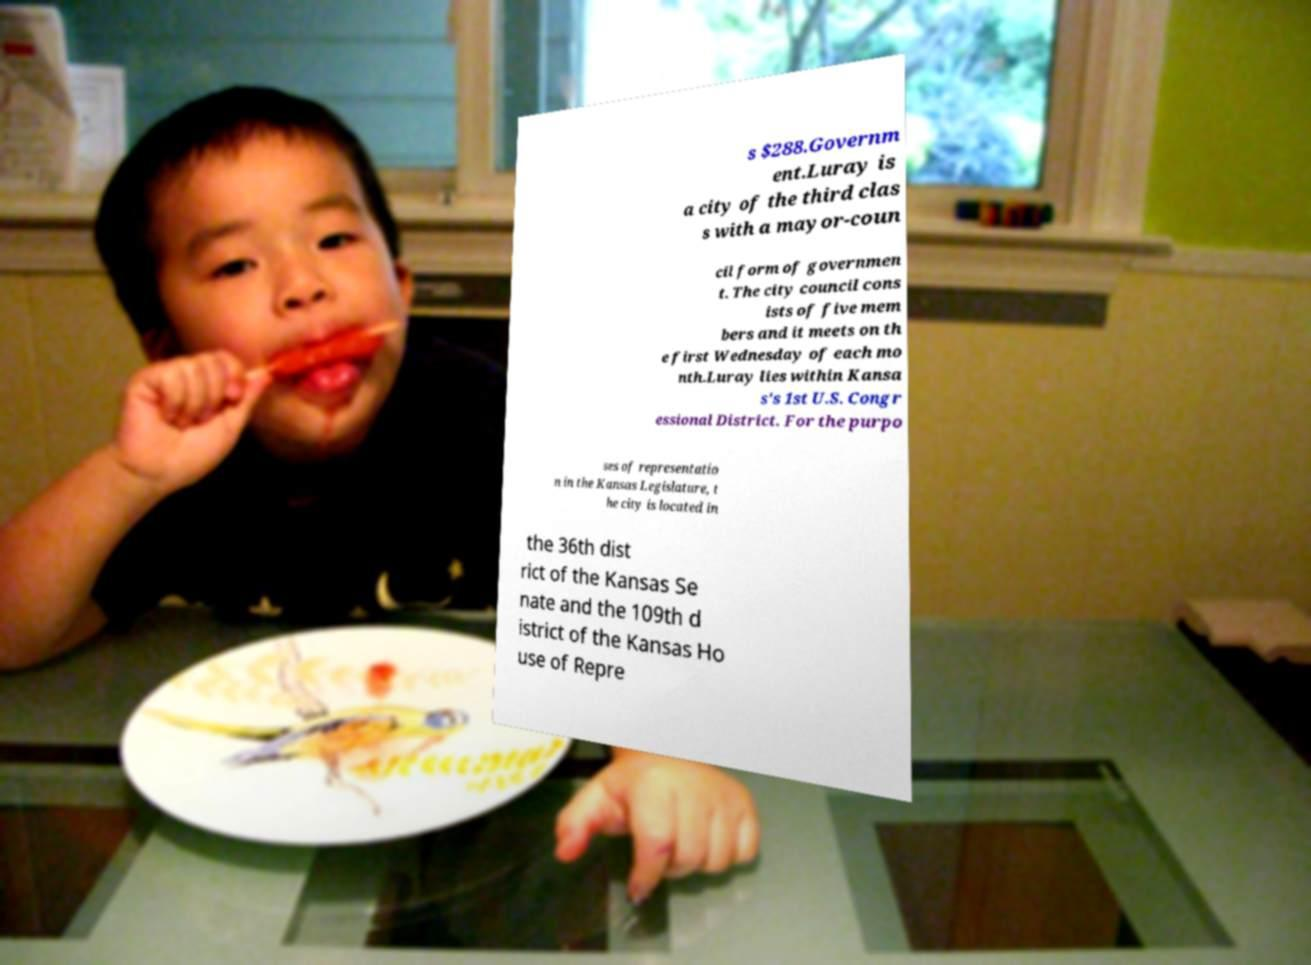Can you read and provide the text displayed in the image?This photo seems to have some interesting text. Can you extract and type it out for me? s $288.Governm ent.Luray is a city of the third clas s with a mayor-coun cil form of governmen t. The city council cons ists of five mem bers and it meets on th e first Wednesday of each mo nth.Luray lies within Kansa s's 1st U.S. Congr essional District. For the purpo ses of representatio n in the Kansas Legislature, t he city is located in the 36th dist rict of the Kansas Se nate and the 109th d istrict of the Kansas Ho use of Repre 